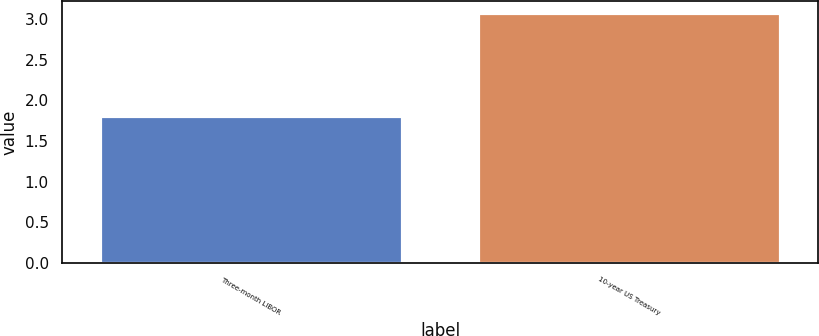Convert chart. <chart><loc_0><loc_0><loc_500><loc_500><bar_chart><fcel>Three-month LIBOR<fcel>10-year US Treasury<nl><fcel>1.81<fcel>3.07<nl></chart> 